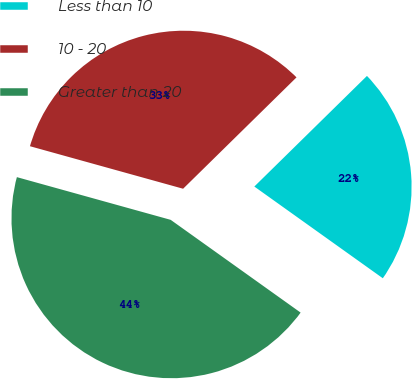<chart> <loc_0><loc_0><loc_500><loc_500><pie_chart><fcel>Less than 10<fcel>10 - 20<fcel>Greater than 20<nl><fcel>22.22%<fcel>33.33%<fcel>44.44%<nl></chart> 